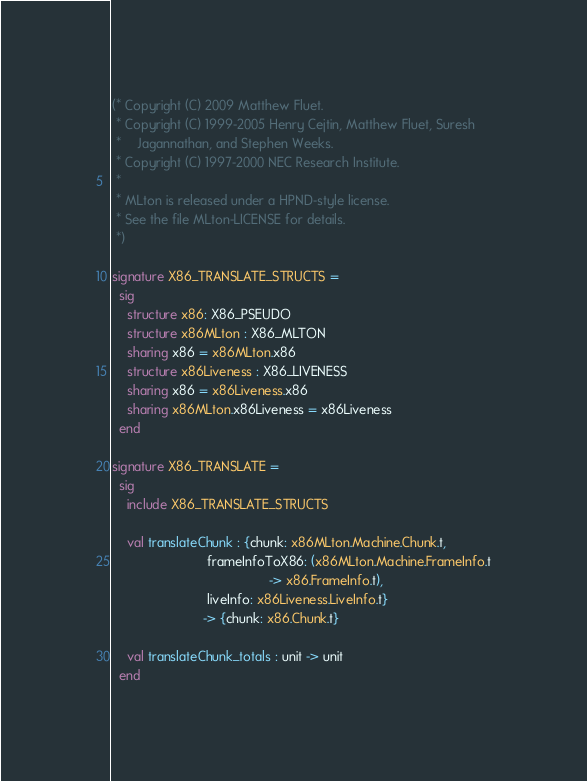Convert code to text. <code><loc_0><loc_0><loc_500><loc_500><_SML_>(* Copyright (C) 2009 Matthew Fluet.
 * Copyright (C) 1999-2005 Henry Cejtin, Matthew Fluet, Suresh
 *    Jagannathan, and Stephen Weeks.
 * Copyright (C) 1997-2000 NEC Research Institute.
 *
 * MLton is released under a HPND-style license.
 * See the file MLton-LICENSE for details.
 *)

signature X86_TRANSLATE_STRUCTS =
  sig
    structure x86: X86_PSEUDO
    structure x86MLton : X86_MLTON
    sharing x86 = x86MLton.x86
    structure x86Liveness : X86_LIVENESS
    sharing x86 = x86Liveness.x86
    sharing x86MLton.x86Liveness = x86Liveness 
  end

signature X86_TRANSLATE =
  sig
    include X86_TRANSLATE_STRUCTS

    val translateChunk : {chunk: x86MLton.Machine.Chunk.t,
                          frameInfoToX86: (x86MLton.Machine.FrameInfo.t
                                           -> x86.FrameInfo.t),
                          liveInfo: x86Liveness.LiveInfo.t}
                         -> {chunk: x86.Chunk.t}

    val translateChunk_totals : unit -> unit
  end
</code> 